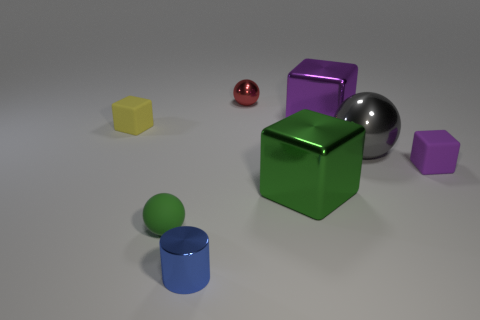Are there any other things that have the same shape as the blue shiny object?
Give a very brief answer. No. The big green thing has what shape?
Ensure brevity in your answer.  Cube. Is the large block in front of the big purple metallic object made of the same material as the small block that is to the left of the cylinder?
Ensure brevity in your answer.  No. How many things are the same color as the small matte ball?
Give a very brief answer. 1. There is a thing that is on the left side of the small blue metallic object and in front of the big green metal object; what shape is it?
Make the answer very short. Sphere. There is a thing that is both left of the blue metal cylinder and to the right of the tiny yellow matte block; what is its color?
Give a very brief answer. Green. Is the number of purple metallic cubes behind the large green object greater than the number of green shiny objects to the right of the large gray shiny ball?
Your answer should be compact. Yes. There is a tiny matte cube that is in front of the yellow thing; what is its color?
Provide a short and direct response. Purple. Do the purple object on the right side of the big gray shiny ball and the big shiny object that is left of the large purple cube have the same shape?
Give a very brief answer. Yes. Is there another rubber cube of the same size as the green cube?
Offer a very short reply. No. 